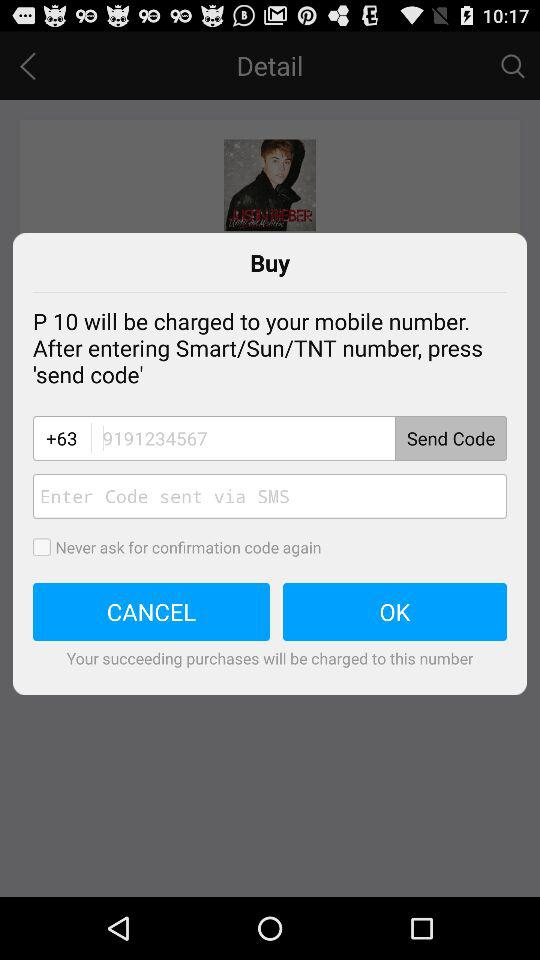What is the entered number? The entered number is 9191234567. 